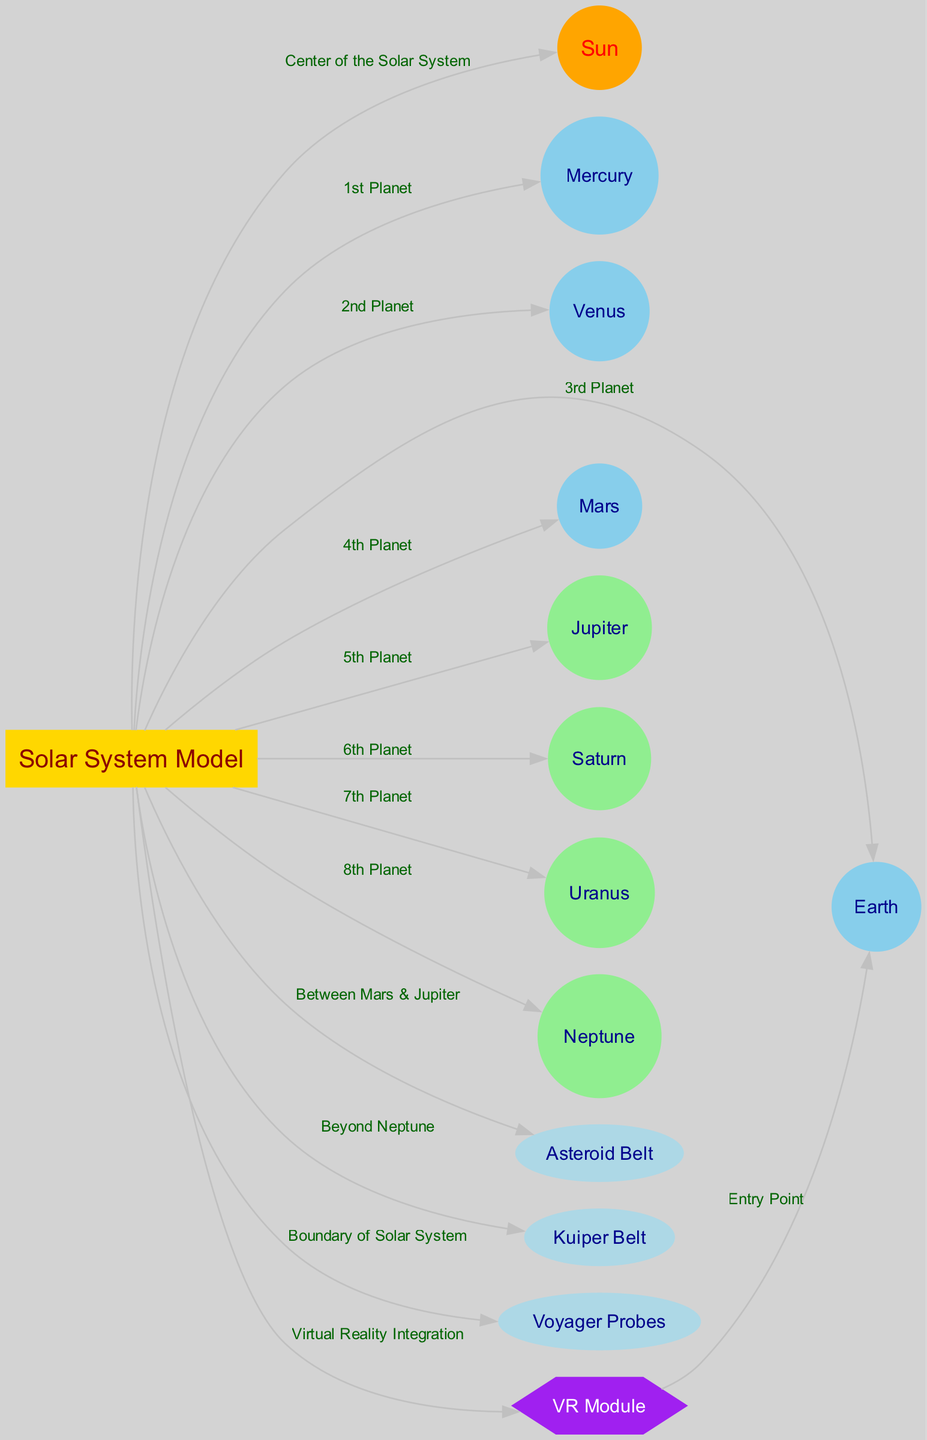What's at the center of the Solar System? The diagram indicates that the node "Sun" is at the center of the Solar System model, as it directly connects to the "Solar System Model" node with the label "Center of the Solar System."
Answer: Sun How many planets are represented in the model? The diagram includes ten nodes for planets: Mercury, Venus, Earth, Mars, Jupiter, Saturn, Uranus, and Neptune. Counting these, there are eight planets.
Answer: 8 Which planet is the fourth from the Sun? The diagram specifies that Mars is connected to the "Solar System Model" with the label "4th Planet," indicating its position as the fourth planet from the Sun.
Answer: Mars What is the relationship between the Solar System Model and the VR Module? The diagram shows an edge from the "Solar System Model" to the "VR Module" with the label "Virtual Reality Integration," indicating that the VR Module is integrated into the Solar System Model.
Answer: Virtual Reality Integration Where is the Asteroid Belt located in relation to the planets? The diagram indicates that the "Asteroid Belt" is connected to the "Solar System Model" with the label "Between Mars & Jupiter," which specifies its location in the solar system.
Answer: Between Mars & Jupiter What entry point is designated for the VR Module? The diagram shows that the "Earth" node is connected to the "VR Module" with the label "Entry Point," indicating where users begin their virtual reality experience.
Answer: Earth Which celestial structures are located beyond Neptune? The diagram indicates that the "Kuiper Belt" is connected to the "Solar System Model" with the label "Beyond Neptune," thus describing its position relative to the planets.
Answer: Kuiper Belt How many nodes are involved in the Solar System Model? The diagram contains a total of twelve nodes, including the Solar System Model itself, eight planets, the Asteroid Belt, the Kuiper Belt, the Voyager Probes, and the VR Module. Thus, the count of nodes is 12.
Answer: 12 What do the Voyager Probes signify in the diagram? In the diagram, the "Voyager Probes" node connects to the "Solar System Model" with the label "Boundary of Solar System," indicating their role in marking the outermost extent of the Solar System.
Answer: Boundary of Solar System 